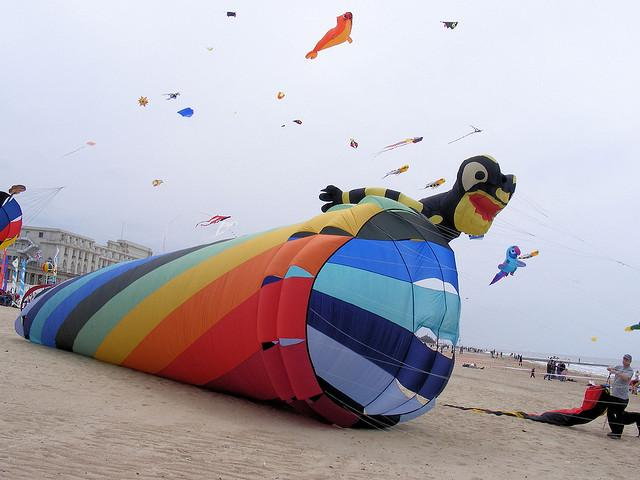What is the large item on the sand shaped like? cone 